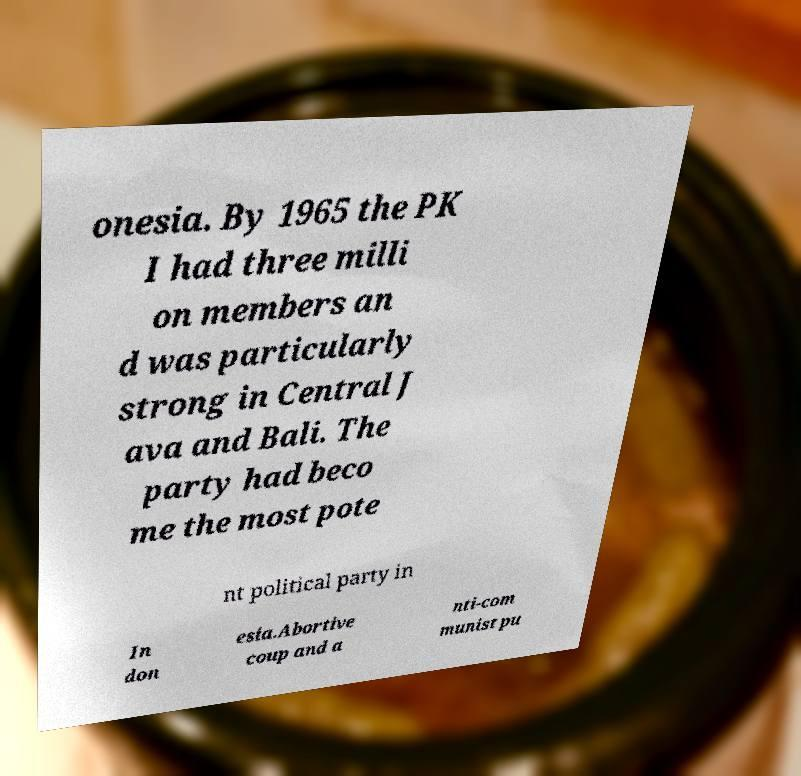What messages or text are displayed in this image? I need them in a readable, typed format. onesia. By 1965 the PK I had three milli on members an d was particularly strong in Central J ava and Bali. The party had beco me the most pote nt political party in In don esia.Abortive coup and a nti-com munist pu 